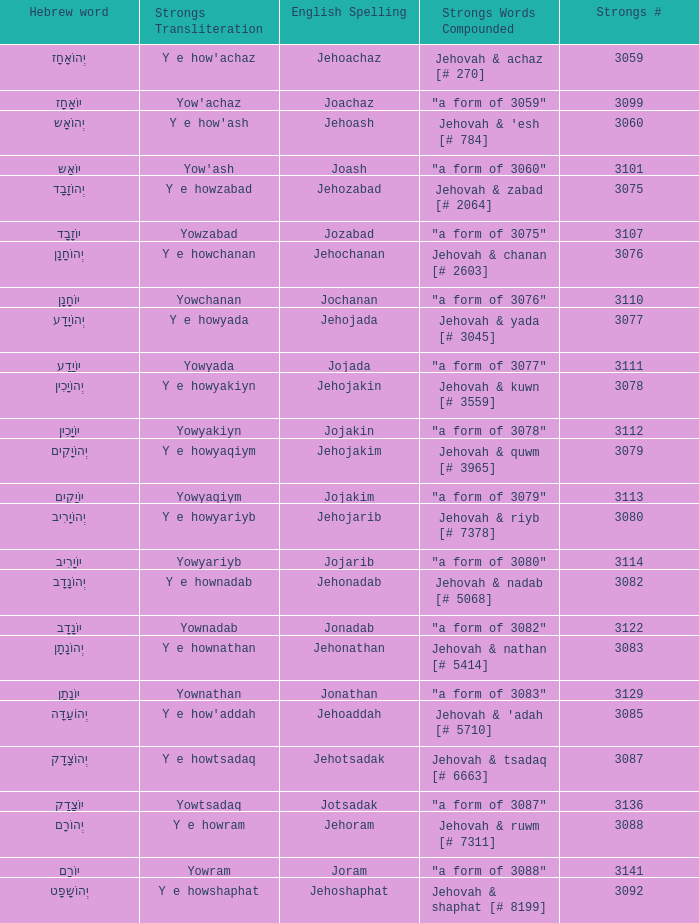What is the english spelling of the word that has the strongs trasliteration of y e howram? Jehoram. 